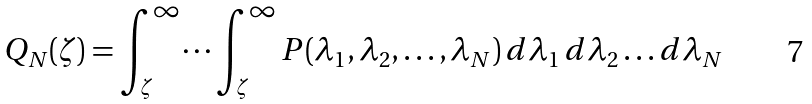<formula> <loc_0><loc_0><loc_500><loc_500>Q _ { N } ( \zeta ) = \int _ { \zeta } ^ { \infty } \dots \int _ { \zeta } ^ { \infty } P ( \lambda _ { 1 } , \lambda _ { 2 } , \dots , \lambda _ { N } ) \, d \lambda _ { 1 } \, d \lambda _ { 2 } \dots d \lambda _ { N }</formula> 